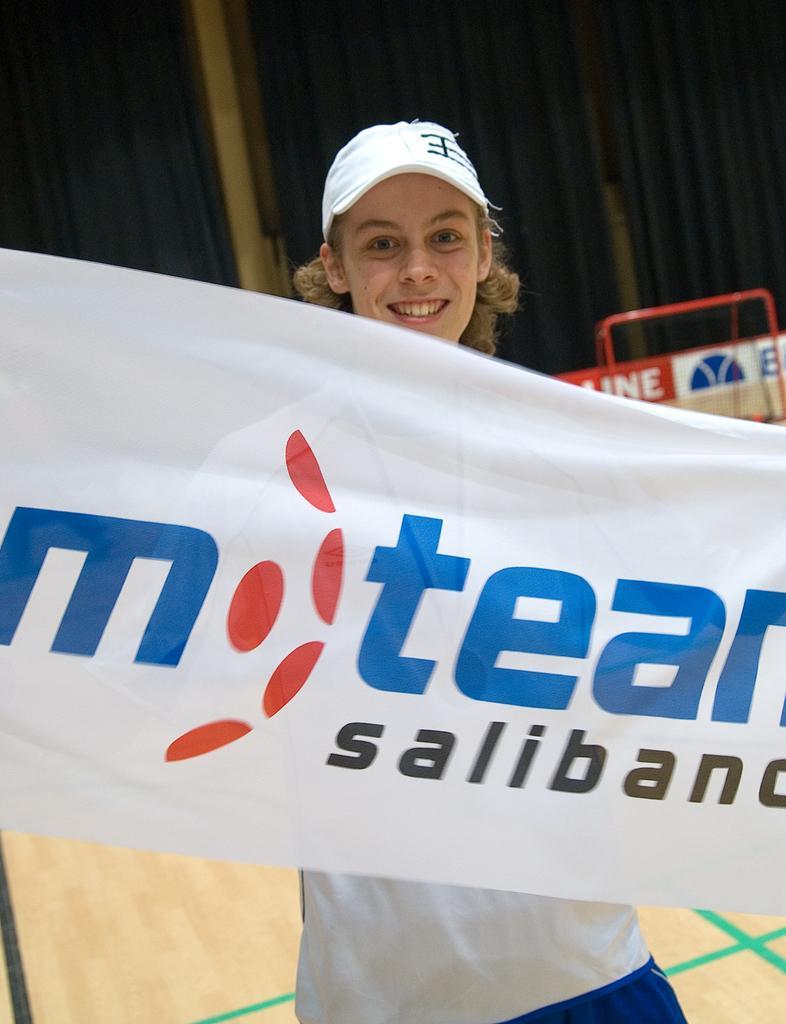Could you give a brief overview of what you see in this image? There is a person wearing cap. In front of her there is a banner with something written. In the background there is banner, red color stand and curtain. 